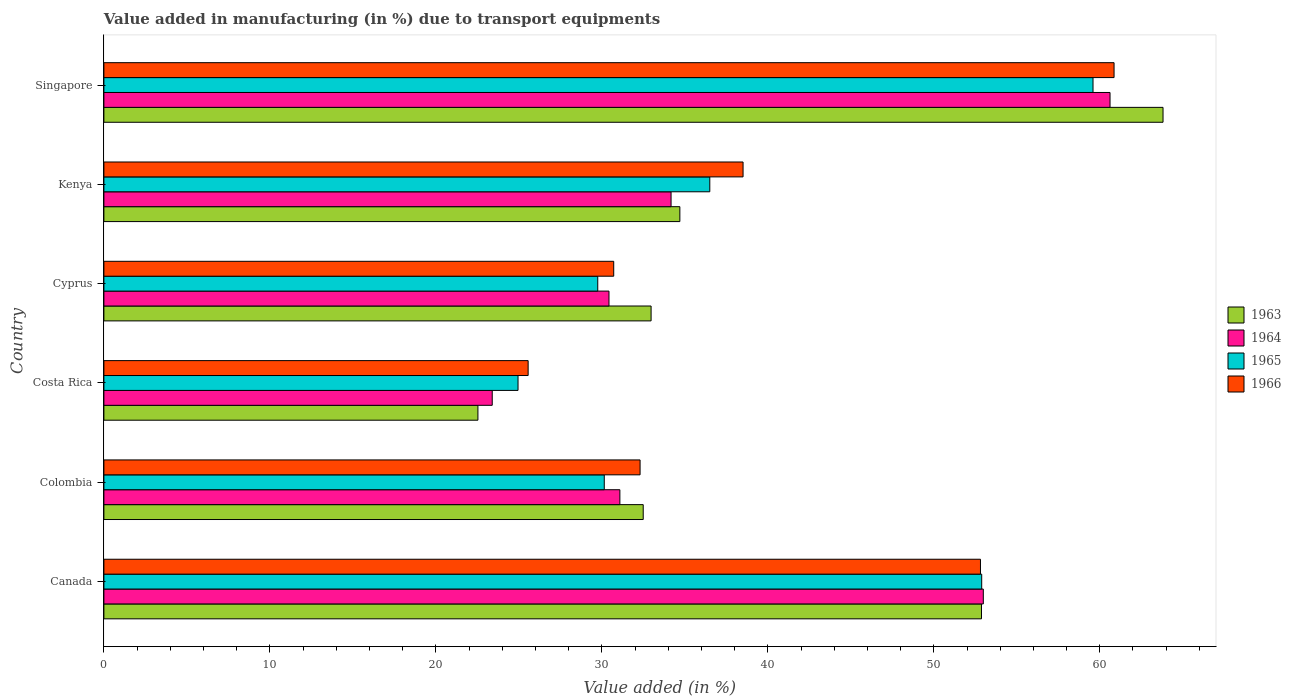How many different coloured bars are there?
Give a very brief answer. 4. How many groups of bars are there?
Give a very brief answer. 6. Are the number of bars per tick equal to the number of legend labels?
Offer a terse response. Yes. Are the number of bars on each tick of the Y-axis equal?
Offer a very short reply. Yes. How many bars are there on the 2nd tick from the top?
Offer a very short reply. 4. How many bars are there on the 5th tick from the bottom?
Offer a terse response. 4. What is the label of the 2nd group of bars from the top?
Your response must be concise. Kenya. What is the percentage of value added in manufacturing due to transport equipments in 1965 in Canada?
Make the answer very short. 52.89. Across all countries, what is the maximum percentage of value added in manufacturing due to transport equipments in 1964?
Ensure brevity in your answer.  60.62. Across all countries, what is the minimum percentage of value added in manufacturing due to transport equipments in 1966?
Give a very brief answer. 25.56. In which country was the percentage of value added in manufacturing due to transport equipments in 1966 maximum?
Your response must be concise. Singapore. What is the total percentage of value added in manufacturing due to transport equipments in 1966 in the graph?
Make the answer very short. 240.76. What is the difference between the percentage of value added in manufacturing due to transport equipments in 1964 in Canada and that in Colombia?
Offer a terse response. 21.9. What is the difference between the percentage of value added in manufacturing due to transport equipments in 1963 in Costa Rica and the percentage of value added in manufacturing due to transport equipments in 1966 in Singapore?
Your answer should be compact. -38.33. What is the average percentage of value added in manufacturing due to transport equipments in 1964 per country?
Offer a very short reply. 38.78. What is the difference between the percentage of value added in manufacturing due to transport equipments in 1965 and percentage of value added in manufacturing due to transport equipments in 1963 in Canada?
Provide a short and direct response. 0.01. What is the ratio of the percentage of value added in manufacturing due to transport equipments in 1963 in Colombia to that in Cyprus?
Your answer should be very brief. 0.99. Is the percentage of value added in manufacturing due to transport equipments in 1964 in Canada less than that in Kenya?
Provide a succinct answer. No. What is the difference between the highest and the second highest percentage of value added in manufacturing due to transport equipments in 1965?
Offer a terse response. 6.71. What is the difference between the highest and the lowest percentage of value added in manufacturing due to transport equipments in 1966?
Your answer should be compact. 35.3. In how many countries, is the percentage of value added in manufacturing due to transport equipments in 1965 greater than the average percentage of value added in manufacturing due to transport equipments in 1965 taken over all countries?
Your answer should be compact. 2. Is it the case that in every country, the sum of the percentage of value added in manufacturing due to transport equipments in 1966 and percentage of value added in manufacturing due to transport equipments in 1963 is greater than the sum of percentage of value added in manufacturing due to transport equipments in 1965 and percentage of value added in manufacturing due to transport equipments in 1964?
Make the answer very short. No. What does the 2nd bar from the top in Cyprus represents?
Your answer should be compact. 1965. What does the 4th bar from the bottom in Singapore represents?
Make the answer very short. 1966. Is it the case that in every country, the sum of the percentage of value added in manufacturing due to transport equipments in 1965 and percentage of value added in manufacturing due to transport equipments in 1966 is greater than the percentage of value added in manufacturing due to transport equipments in 1964?
Keep it short and to the point. Yes. How many bars are there?
Your response must be concise. 24. What is the difference between two consecutive major ticks on the X-axis?
Your answer should be very brief. 10. Are the values on the major ticks of X-axis written in scientific E-notation?
Provide a short and direct response. No. Does the graph contain grids?
Offer a terse response. No. How many legend labels are there?
Give a very brief answer. 4. What is the title of the graph?
Make the answer very short. Value added in manufacturing (in %) due to transport equipments. What is the label or title of the X-axis?
Ensure brevity in your answer.  Value added (in %). What is the label or title of the Y-axis?
Provide a succinct answer. Country. What is the Value added (in %) in 1963 in Canada?
Keep it short and to the point. 52.87. What is the Value added (in %) of 1964 in Canada?
Make the answer very short. 52.98. What is the Value added (in %) in 1965 in Canada?
Ensure brevity in your answer.  52.89. What is the Value added (in %) in 1966 in Canada?
Offer a very short reply. 52.81. What is the Value added (in %) in 1963 in Colombia?
Give a very brief answer. 32.49. What is the Value added (in %) in 1964 in Colombia?
Your answer should be very brief. 31.09. What is the Value added (in %) of 1965 in Colombia?
Ensure brevity in your answer.  30.15. What is the Value added (in %) in 1966 in Colombia?
Ensure brevity in your answer.  32.3. What is the Value added (in %) of 1963 in Costa Rica?
Provide a succinct answer. 22.53. What is the Value added (in %) of 1964 in Costa Rica?
Offer a very short reply. 23.4. What is the Value added (in %) in 1965 in Costa Rica?
Offer a terse response. 24.95. What is the Value added (in %) in 1966 in Costa Rica?
Keep it short and to the point. 25.56. What is the Value added (in %) of 1963 in Cyprus?
Your response must be concise. 32.97. What is the Value added (in %) of 1964 in Cyprus?
Give a very brief answer. 30.43. What is the Value added (in %) of 1965 in Cyprus?
Offer a very short reply. 29.75. What is the Value added (in %) of 1966 in Cyprus?
Make the answer very short. 30.72. What is the Value added (in %) of 1963 in Kenya?
Ensure brevity in your answer.  34.7. What is the Value added (in %) in 1964 in Kenya?
Give a very brief answer. 34.17. What is the Value added (in %) in 1965 in Kenya?
Provide a short and direct response. 36.5. What is the Value added (in %) of 1966 in Kenya?
Make the answer very short. 38.51. What is the Value added (in %) in 1963 in Singapore?
Ensure brevity in your answer.  63.81. What is the Value added (in %) in 1964 in Singapore?
Your answer should be very brief. 60.62. What is the Value added (in %) of 1965 in Singapore?
Your answer should be compact. 59.59. What is the Value added (in %) of 1966 in Singapore?
Give a very brief answer. 60.86. Across all countries, what is the maximum Value added (in %) in 1963?
Offer a terse response. 63.81. Across all countries, what is the maximum Value added (in %) in 1964?
Your response must be concise. 60.62. Across all countries, what is the maximum Value added (in %) of 1965?
Make the answer very short. 59.59. Across all countries, what is the maximum Value added (in %) in 1966?
Offer a terse response. 60.86. Across all countries, what is the minimum Value added (in %) of 1963?
Offer a very short reply. 22.53. Across all countries, what is the minimum Value added (in %) in 1964?
Offer a terse response. 23.4. Across all countries, what is the minimum Value added (in %) of 1965?
Ensure brevity in your answer.  24.95. Across all countries, what is the minimum Value added (in %) in 1966?
Ensure brevity in your answer.  25.56. What is the total Value added (in %) of 1963 in the graph?
Offer a very short reply. 239.38. What is the total Value added (in %) of 1964 in the graph?
Make the answer very short. 232.68. What is the total Value added (in %) of 1965 in the graph?
Offer a very short reply. 233.83. What is the total Value added (in %) of 1966 in the graph?
Offer a terse response. 240.76. What is the difference between the Value added (in %) in 1963 in Canada and that in Colombia?
Your response must be concise. 20.38. What is the difference between the Value added (in %) of 1964 in Canada and that in Colombia?
Your response must be concise. 21.9. What is the difference between the Value added (in %) of 1965 in Canada and that in Colombia?
Give a very brief answer. 22.74. What is the difference between the Value added (in %) of 1966 in Canada and that in Colombia?
Offer a terse response. 20.51. What is the difference between the Value added (in %) of 1963 in Canada and that in Costa Rica?
Offer a very short reply. 30.34. What is the difference between the Value added (in %) in 1964 in Canada and that in Costa Rica?
Give a very brief answer. 29.59. What is the difference between the Value added (in %) of 1965 in Canada and that in Costa Rica?
Ensure brevity in your answer.  27.93. What is the difference between the Value added (in %) in 1966 in Canada and that in Costa Rica?
Ensure brevity in your answer.  27.25. What is the difference between the Value added (in %) of 1963 in Canada and that in Cyprus?
Offer a terse response. 19.91. What is the difference between the Value added (in %) of 1964 in Canada and that in Cyprus?
Provide a short and direct response. 22.55. What is the difference between the Value added (in %) in 1965 in Canada and that in Cyprus?
Give a very brief answer. 23.13. What is the difference between the Value added (in %) in 1966 in Canada and that in Cyprus?
Your response must be concise. 22.1. What is the difference between the Value added (in %) in 1963 in Canada and that in Kenya?
Offer a terse response. 18.17. What is the difference between the Value added (in %) of 1964 in Canada and that in Kenya?
Keep it short and to the point. 18.81. What is the difference between the Value added (in %) in 1965 in Canada and that in Kenya?
Your answer should be very brief. 16.38. What is the difference between the Value added (in %) in 1966 in Canada and that in Kenya?
Provide a short and direct response. 14.3. What is the difference between the Value added (in %) in 1963 in Canada and that in Singapore?
Make the answer very short. -10.94. What is the difference between the Value added (in %) of 1964 in Canada and that in Singapore?
Keep it short and to the point. -7.63. What is the difference between the Value added (in %) in 1965 in Canada and that in Singapore?
Your response must be concise. -6.71. What is the difference between the Value added (in %) of 1966 in Canada and that in Singapore?
Make the answer very short. -8.05. What is the difference between the Value added (in %) in 1963 in Colombia and that in Costa Rica?
Make the answer very short. 9.96. What is the difference between the Value added (in %) of 1964 in Colombia and that in Costa Rica?
Offer a very short reply. 7.69. What is the difference between the Value added (in %) in 1965 in Colombia and that in Costa Rica?
Keep it short and to the point. 5.2. What is the difference between the Value added (in %) of 1966 in Colombia and that in Costa Rica?
Provide a succinct answer. 6.74. What is the difference between the Value added (in %) of 1963 in Colombia and that in Cyprus?
Give a very brief answer. -0.47. What is the difference between the Value added (in %) of 1964 in Colombia and that in Cyprus?
Offer a terse response. 0.66. What is the difference between the Value added (in %) in 1965 in Colombia and that in Cyprus?
Ensure brevity in your answer.  0.39. What is the difference between the Value added (in %) in 1966 in Colombia and that in Cyprus?
Offer a very short reply. 1.59. What is the difference between the Value added (in %) in 1963 in Colombia and that in Kenya?
Your answer should be very brief. -2.21. What is the difference between the Value added (in %) in 1964 in Colombia and that in Kenya?
Give a very brief answer. -3.08. What is the difference between the Value added (in %) of 1965 in Colombia and that in Kenya?
Ensure brevity in your answer.  -6.36. What is the difference between the Value added (in %) of 1966 in Colombia and that in Kenya?
Offer a terse response. -6.2. What is the difference between the Value added (in %) in 1963 in Colombia and that in Singapore?
Make the answer very short. -31.32. What is the difference between the Value added (in %) of 1964 in Colombia and that in Singapore?
Your answer should be compact. -29.53. What is the difference between the Value added (in %) in 1965 in Colombia and that in Singapore?
Offer a terse response. -29.45. What is the difference between the Value added (in %) in 1966 in Colombia and that in Singapore?
Provide a short and direct response. -28.56. What is the difference between the Value added (in %) of 1963 in Costa Rica and that in Cyprus?
Ensure brevity in your answer.  -10.43. What is the difference between the Value added (in %) in 1964 in Costa Rica and that in Cyprus?
Offer a very short reply. -7.03. What is the difference between the Value added (in %) of 1965 in Costa Rica and that in Cyprus?
Make the answer very short. -4.8. What is the difference between the Value added (in %) in 1966 in Costa Rica and that in Cyprus?
Make the answer very short. -5.16. What is the difference between the Value added (in %) in 1963 in Costa Rica and that in Kenya?
Make the answer very short. -12.17. What is the difference between the Value added (in %) of 1964 in Costa Rica and that in Kenya?
Provide a short and direct response. -10.77. What is the difference between the Value added (in %) in 1965 in Costa Rica and that in Kenya?
Ensure brevity in your answer.  -11.55. What is the difference between the Value added (in %) in 1966 in Costa Rica and that in Kenya?
Your answer should be very brief. -12.95. What is the difference between the Value added (in %) of 1963 in Costa Rica and that in Singapore?
Your answer should be compact. -41.28. What is the difference between the Value added (in %) in 1964 in Costa Rica and that in Singapore?
Your answer should be very brief. -37.22. What is the difference between the Value added (in %) in 1965 in Costa Rica and that in Singapore?
Ensure brevity in your answer.  -34.64. What is the difference between the Value added (in %) in 1966 in Costa Rica and that in Singapore?
Keep it short and to the point. -35.3. What is the difference between the Value added (in %) of 1963 in Cyprus and that in Kenya?
Offer a very short reply. -1.73. What is the difference between the Value added (in %) of 1964 in Cyprus and that in Kenya?
Your answer should be compact. -3.74. What is the difference between the Value added (in %) of 1965 in Cyprus and that in Kenya?
Ensure brevity in your answer.  -6.75. What is the difference between the Value added (in %) in 1966 in Cyprus and that in Kenya?
Provide a short and direct response. -7.79. What is the difference between the Value added (in %) of 1963 in Cyprus and that in Singapore?
Your answer should be compact. -30.84. What is the difference between the Value added (in %) of 1964 in Cyprus and that in Singapore?
Your answer should be very brief. -30.19. What is the difference between the Value added (in %) in 1965 in Cyprus and that in Singapore?
Keep it short and to the point. -29.84. What is the difference between the Value added (in %) in 1966 in Cyprus and that in Singapore?
Offer a terse response. -30.14. What is the difference between the Value added (in %) in 1963 in Kenya and that in Singapore?
Your answer should be compact. -29.11. What is the difference between the Value added (in %) in 1964 in Kenya and that in Singapore?
Make the answer very short. -26.45. What is the difference between the Value added (in %) in 1965 in Kenya and that in Singapore?
Your response must be concise. -23.09. What is the difference between the Value added (in %) of 1966 in Kenya and that in Singapore?
Your response must be concise. -22.35. What is the difference between the Value added (in %) in 1963 in Canada and the Value added (in %) in 1964 in Colombia?
Make the answer very short. 21.79. What is the difference between the Value added (in %) in 1963 in Canada and the Value added (in %) in 1965 in Colombia?
Your answer should be compact. 22.73. What is the difference between the Value added (in %) in 1963 in Canada and the Value added (in %) in 1966 in Colombia?
Keep it short and to the point. 20.57. What is the difference between the Value added (in %) in 1964 in Canada and the Value added (in %) in 1965 in Colombia?
Make the answer very short. 22.84. What is the difference between the Value added (in %) in 1964 in Canada and the Value added (in %) in 1966 in Colombia?
Ensure brevity in your answer.  20.68. What is the difference between the Value added (in %) in 1965 in Canada and the Value added (in %) in 1966 in Colombia?
Offer a terse response. 20.58. What is the difference between the Value added (in %) in 1963 in Canada and the Value added (in %) in 1964 in Costa Rica?
Your answer should be very brief. 29.48. What is the difference between the Value added (in %) in 1963 in Canada and the Value added (in %) in 1965 in Costa Rica?
Your answer should be very brief. 27.92. What is the difference between the Value added (in %) in 1963 in Canada and the Value added (in %) in 1966 in Costa Rica?
Give a very brief answer. 27.31. What is the difference between the Value added (in %) in 1964 in Canada and the Value added (in %) in 1965 in Costa Rica?
Your answer should be compact. 28.03. What is the difference between the Value added (in %) in 1964 in Canada and the Value added (in %) in 1966 in Costa Rica?
Provide a short and direct response. 27.42. What is the difference between the Value added (in %) in 1965 in Canada and the Value added (in %) in 1966 in Costa Rica?
Provide a succinct answer. 27.33. What is the difference between the Value added (in %) in 1963 in Canada and the Value added (in %) in 1964 in Cyprus?
Offer a very short reply. 22.44. What is the difference between the Value added (in %) in 1963 in Canada and the Value added (in %) in 1965 in Cyprus?
Keep it short and to the point. 23.12. What is the difference between the Value added (in %) in 1963 in Canada and the Value added (in %) in 1966 in Cyprus?
Your answer should be compact. 22.16. What is the difference between the Value added (in %) of 1964 in Canada and the Value added (in %) of 1965 in Cyprus?
Offer a very short reply. 23.23. What is the difference between the Value added (in %) in 1964 in Canada and the Value added (in %) in 1966 in Cyprus?
Offer a terse response. 22.27. What is the difference between the Value added (in %) of 1965 in Canada and the Value added (in %) of 1966 in Cyprus?
Ensure brevity in your answer.  22.17. What is the difference between the Value added (in %) of 1963 in Canada and the Value added (in %) of 1964 in Kenya?
Your answer should be compact. 18.7. What is the difference between the Value added (in %) in 1963 in Canada and the Value added (in %) in 1965 in Kenya?
Make the answer very short. 16.37. What is the difference between the Value added (in %) of 1963 in Canada and the Value added (in %) of 1966 in Kenya?
Your response must be concise. 14.37. What is the difference between the Value added (in %) of 1964 in Canada and the Value added (in %) of 1965 in Kenya?
Give a very brief answer. 16.48. What is the difference between the Value added (in %) of 1964 in Canada and the Value added (in %) of 1966 in Kenya?
Provide a short and direct response. 14.47. What is the difference between the Value added (in %) in 1965 in Canada and the Value added (in %) in 1966 in Kenya?
Your answer should be very brief. 14.38. What is the difference between the Value added (in %) in 1963 in Canada and the Value added (in %) in 1964 in Singapore?
Your answer should be very brief. -7.74. What is the difference between the Value added (in %) in 1963 in Canada and the Value added (in %) in 1965 in Singapore?
Your answer should be compact. -6.72. What is the difference between the Value added (in %) of 1963 in Canada and the Value added (in %) of 1966 in Singapore?
Ensure brevity in your answer.  -7.99. What is the difference between the Value added (in %) in 1964 in Canada and the Value added (in %) in 1965 in Singapore?
Ensure brevity in your answer.  -6.61. What is the difference between the Value added (in %) of 1964 in Canada and the Value added (in %) of 1966 in Singapore?
Your answer should be very brief. -7.88. What is the difference between the Value added (in %) of 1965 in Canada and the Value added (in %) of 1966 in Singapore?
Your answer should be compact. -7.97. What is the difference between the Value added (in %) of 1963 in Colombia and the Value added (in %) of 1964 in Costa Rica?
Your response must be concise. 9.1. What is the difference between the Value added (in %) of 1963 in Colombia and the Value added (in %) of 1965 in Costa Rica?
Your answer should be very brief. 7.54. What is the difference between the Value added (in %) of 1963 in Colombia and the Value added (in %) of 1966 in Costa Rica?
Ensure brevity in your answer.  6.93. What is the difference between the Value added (in %) in 1964 in Colombia and the Value added (in %) in 1965 in Costa Rica?
Make the answer very short. 6.14. What is the difference between the Value added (in %) of 1964 in Colombia and the Value added (in %) of 1966 in Costa Rica?
Offer a terse response. 5.53. What is the difference between the Value added (in %) in 1965 in Colombia and the Value added (in %) in 1966 in Costa Rica?
Make the answer very short. 4.59. What is the difference between the Value added (in %) in 1963 in Colombia and the Value added (in %) in 1964 in Cyprus?
Your answer should be compact. 2.06. What is the difference between the Value added (in %) of 1963 in Colombia and the Value added (in %) of 1965 in Cyprus?
Give a very brief answer. 2.74. What is the difference between the Value added (in %) in 1963 in Colombia and the Value added (in %) in 1966 in Cyprus?
Offer a terse response. 1.78. What is the difference between the Value added (in %) of 1964 in Colombia and the Value added (in %) of 1965 in Cyprus?
Provide a succinct answer. 1.33. What is the difference between the Value added (in %) of 1964 in Colombia and the Value added (in %) of 1966 in Cyprus?
Make the answer very short. 0.37. What is the difference between the Value added (in %) in 1965 in Colombia and the Value added (in %) in 1966 in Cyprus?
Keep it short and to the point. -0.57. What is the difference between the Value added (in %) of 1963 in Colombia and the Value added (in %) of 1964 in Kenya?
Keep it short and to the point. -1.68. What is the difference between the Value added (in %) of 1963 in Colombia and the Value added (in %) of 1965 in Kenya?
Ensure brevity in your answer.  -4.01. What is the difference between the Value added (in %) in 1963 in Colombia and the Value added (in %) in 1966 in Kenya?
Your response must be concise. -6.01. What is the difference between the Value added (in %) in 1964 in Colombia and the Value added (in %) in 1965 in Kenya?
Ensure brevity in your answer.  -5.42. What is the difference between the Value added (in %) of 1964 in Colombia and the Value added (in %) of 1966 in Kenya?
Offer a very short reply. -7.42. What is the difference between the Value added (in %) in 1965 in Colombia and the Value added (in %) in 1966 in Kenya?
Give a very brief answer. -8.36. What is the difference between the Value added (in %) in 1963 in Colombia and the Value added (in %) in 1964 in Singapore?
Ensure brevity in your answer.  -28.12. What is the difference between the Value added (in %) of 1963 in Colombia and the Value added (in %) of 1965 in Singapore?
Give a very brief answer. -27.1. What is the difference between the Value added (in %) in 1963 in Colombia and the Value added (in %) in 1966 in Singapore?
Offer a terse response. -28.37. What is the difference between the Value added (in %) of 1964 in Colombia and the Value added (in %) of 1965 in Singapore?
Offer a terse response. -28.51. What is the difference between the Value added (in %) in 1964 in Colombia and the Value added (in %) in 1966 in Singapore?
Keep it short and to the point. -29.77. What is the difference between the Value added (in %) of 1965 in Colombia and the Value added (in %) of 1966 in Singapore?
Offer a very short reply. -30.71. What is the difference between the Value added (in %) in 1963 in Costa Rica and the Value added (in %) in 1964 in Cyprus?
Your response must be concise. -7.9. What is the difference between the Value added (in %) in 1963 in Costa Rica and the Value added (in %) in 1965 in Cyprus?
Provide a succinct answer. -7.22. What is the difference between the Value added (in %) in 1963 in Costa Rica and the Value added (in %) in 1966 in Cyprus?
Your answer should be compact. -8.18. What is the difference between the Value added (in %) of 1964 in Costa Rica and the Value added (in %) of 1965 in Cyprus?
Your response must be concise. -6.36. What is the difference between the Value added (in %) of 1964 in Costa Rica and the Value added (in %) of 1966 in Cyprus?
Offer a terse response. -7.32. What is the difference between the Value added (in %) in 1965 in Costa Rica and the Value added (in %) in 1966 in Cyprus?
Give a very brief answer. -5.77. What is the difference between the Value added (in %) in 1963 in Costa Rica and the Value added (in %) in 1964 in Kenya?
Offer a very short reply. -11.64. What is the difference between the Value added (in %) in 1963 in Costa Rica and the Value added (in %) in 1965 in Kenya?
Provide a short and direct response. -13.97. What is the difference between the Value added (in %) of 1963 in Costa Rica and the Value added (in %) of 1966 in Kenya?
Ensure brevity in your answer.  -15.97. What is the difference between the Value added (in %) in 1964 in Costa Rica and the Value added (in %) in 1965 in Kenya?
Your response must be concise. -13.11. What is the difference between the Value added (in %) of 1964 in Costa Rica and the Value added (in %) of 1966 in Kenya?
Give a very brief answer. -15.11. What is the difference between the Value added (in %) of 1965 in Costa Rica and the Value added (in %) of 1966 in Kenya?
Ensure brevity in your answer.  -13.56. What is the difference between the Value added (in %) of 1963 in Costa Rica and the Value added (in %) of 1964 in Singapore?
Your answer should be compact. -38.08. What is the difference between the Value added (in %) in 1963 in Costa Rica and the Value added (in %) in 1965 in Singapore?
Your answer should be compact. -37.06. What is the difference between the Value added (in %) in 1963 in Costa Rica and the Value added (in %) in 1966 in Singapore?
Give a very brief answer. -38.33. What is the difference between the Value added (in %) of 1964 in Costa Rica and the Value added (in %) of 1965 in Singapore?
Ensure brevity in your answer.  -36.19. What is the difference between the Value added (in %) in 1964 in Costa Rica and the Value added (in %) in 1966 in Singapore?
Your response must be concise. -37.46. What is the difference between the Value added (in %) in 1965 in Costa Rica and the Value added (in %) in 1966 in Singapore?
Keep it short and to the point. -35.91. What is the difference between the Value added (in %) of 1963 in Cyprus and the Value added (in %) of 1964 in Kenya?
Keep it short and to the point. -1.2. What is the difference between the Value added (in %) of 1963 in Cyprus and the Value added (in %) of 1965 in Kenya?
Your answer should be compact. -3.54. What is the difference between the Value added (in %) in 1963 in Cyprus and the Value added (in %) in 1966 in Kenya?
Ensure brevity in your answer.  -5.54. What is the difference between the Value added (in %) in 1964 in Cyprus and the Value added (in %) in 1965 in Kenya?
Offer a terse response. -6.07. What is the difference between the Value added (in %) of 1964 in Cyprus and the Value added (in %) of 1966 in Kenya?
Offer a terse response. -8.08. What is the difference between the Value added (in %) in 1965 in Cyprus and the Value added (in %) in 1966 in Kenya?
Offer a very short reply. -8.75. What is the difference between the Value added (in %) of 1963 in Cyprus and the Value added (in %) of 1964 in Singapore?
Offer a terse response. -27.65. What is the difference between the Value added (in %) of 1963 in Cyprus and the Value added (in %) of 1965 in Singapore?
Keep it short and to the point. -26.62. What is the difference between the Value added (in %) in 1963 in Cyprus and the Value added (in %) in 1966 in Singapore?
Make the answer very short. -27.89. What is the difference between the Value added (in %) in 1964 in Cyprus and the Value added (in %) in 1965 in Singapore?
Offer a terse response. -29.16. What is the difference between the Value added (in %) of 1964 in Cyprus and the Value added (in %) of 1966 in Singapore?
Make the answer very short. -30.43. What is the difference between the Value added (in %) of 1965 in Cyprus and the Value added (in %) of 1966 in Singapore?
Your response must be concise. -31.11. What is the difference between the Value added (in %) of 1963 in Kenya and the Value added (in %) of 1964 in Singapore?
Your answer should be very brief. -25.92. What is the difference between the Value added (in %) in 1963 in Kenya and the Value added (in %) in 1965 in Singapore?
Provide a short and direct response. -24.89. What is the difference between the Value added (in %) of 1963 in Kenya and the Value added (in %) of 1966 in Singapore?
Provide a succinct answer. -26.16. What is the difference between the Value added (in %) of 1964 in Kenya and the Value added (in %) of 1965 in Singapore?
Make the answer very short. -25.42. What is the difference between the Value added (in %) in 1964 in Kenya and the Value added (in %) in 1966 in Singapore?
Provide a short and direct response. -26.69. What is the difference between the Value added (in %) of 1965 in Kenya and the Value added (in %) of 1966 in Singapore?
Your response must be concise. -24.36. What is the average Value added (in %) in 1963 per country?
Your response must be concise. 39.9. What is the average Value added (in %) of 1964 per country?
Your response must be concise. 38.78. What is the average Value added (in %) in 1965 per country?
Provide a short and direct response. 38.97. What is the average Value added (in %) of 1966 per country?
Give a very brief answer. 40.13. What is the difference between the Value added (in %) in 1963 and Value added (in %) in 1964 in Canada?
Your answer should be compact. -0.11. What is the difference between the Value added (in %) of 1963 and Value added (in %) of 1965 in Canada?
Your answer should be very brief. -0.01. What is the difference between the Value added (in %) of 1963 and Value added (in %) of 1966 in Canada?
Give a very brief answer. 0.06. What is the difference between the Value added (in %) in 1964 and Value added (in %) in 1965 in Canada?
Provide a succinct answer. 0.1. What is the difference between the Value added (in %) of 1964 and Value added (in %) of 1966 in Canada?
Make the answer very short. 0.17. What is the difference between the Value added (in %) of 1965 and Value added (in %) of 1966 in Canada?
Your answer should be very brief. 0.07. What is the difference between the Value added (in %) of 1963 and Value added (in %) of 1964 in Colombia?
Provide a succinct answer. 1.41. What is the difference between the Value added (in %) in 1963 and Value added (in %) in 1965 in Colombia?
Offer a very short reply. 2.35. What is the difference between the Value added (in %) in 1963 and Value added (in %) in 1966 in Colombia?
Ensure brevity in your answer.  0.19. What is the difference between the Value added (in %) of 1964 and Value added (in %) of 1965 in Colombia?
Keep it short and to the point. 0.94. What is the difference between the Value added (in %) of 1964 and Value added (in %) of 1966 in Colombia?
Provide a succinct answer. -1.22. What is the difference between the Value added (in %) of 1965 and Value added (in %) of 1966 in Colombia?
Your response must be concise. -2.16. What is the difference between the Value added (in %) in 1963 and Value added (in %) in 1964 in Costa Rica?
Your response must be concise. -0.86. What is the difference between the Value added (in %) in 1963 and Value added (in %) in 1965 in Costa Rica?
Give a very brief answer. -2.42. What is the difference between the Value added (in %) of 1963 and Value added (in %) of 1966 in Costa Rica?
Offer a terse response. -3.03. What is the difference between the Value added (in %) of 1964 and Value added (in %) of 1965 in Costa Rica?
Your response must be concise. -1.55. What is the difference between the Value added (in %) of 1964 and Value added (in %) of 1966 in Costa Rica?
Your answer should be compact. -2.16. What is the difference between the Value added (in %) in 1965 and Value added (in %) in 1966 in Costa Rica?
Make the answer very short. -0.61. What is the difference between the Value added (in %) in 1963 and Value added (in %) in 1964 in Cyprus?
Keep it short and to the point. 2.54. What is the difference between the Value added (in %) of 1963 and Value added (in %) of 1965 in Cyprus?
Offer a very short reply. 3.21. What is the difference between the Value added (in %) of 1963 and Value added (in %) of 1966 in Cyprus?
Your answer should be very brief. 2.25. What is the difference between the Value added (in %) of 1964 and Value added (in %) of 1965 in Cyprus?
Make the answer very short. 0.68. What is the difference between the Value added (in %) of 1964 and Value added (in %) of 1966 in Cyprus?
Offer a terse response. -0.29. What is the difference between the Value added (in %) in 1965 and Value added (in %) in 1966 in Cyprus?
Offer a very short reply. -0.96. What is the difference between the Value added (in %) in 1963 and Value added (in %) in 1964 in Kenya?
Keep it short and to the point. 0.53. What is the difference between the Value added (in %) of 1963 and Value added (in %) of 1965 in Kenya?
Your answer should be very brief. -1.8. What is the difference between the Value added (in %) in 1963 and Value added (in %) in 1966 in Kenya?
Your answer should be very brief. -3.81. What is the difference between the Value added (in %) of 1964 and Value added (in %) of 1965 in Kenya?
Ensure brevity in your answer.  -2.33. What is the difference between the Value added (in %) of 1964 and Value added (in %) of 1966 in Kenya?
Give a very brief answer. -4.34. What is the difference between the Value added (in %) of 1965 and Value added (in %) of 1966 in Kenya?
Keep it short and to the point. -2. What is the difference between the Value added (in %) of 1963 and Value added (in %) of 1964 in Singapore?
Ensure brevity in your answer.  3.19. What is the difference between the Value added (in %) of 1963 and Value added (in %) of 1965 in Singapore?
Your answer should be compact. 4.22. What is the difference between the Value added (in %) in 1963 and Value added (in %) in 1966 in Singapore?
Offer a terse response. 2.95. What is the difference between the Value added (in %) of 1964 and Value added (in %) of 1965 in Singapore?
Ensure brevity in your answer.  1.03. What is the difference between the Value added (in %) of 1964 and Value added (in %) of 1966 in Singapore?
Provide a short and direct response. -0.24. What is the difference between the Value added (in %) in 1965 and Value added (in %) in 1966 in Singapore?
Keep it short and to the point. -1.27. What is the ratio of the Value added (in %) of 1963 in Canada to that in Colombia?
Keep it short and to the point. 1.63. What is the ratio of the Value added (in %) of 1964 in Canada to that in Colombia?
Offer a terse response. 1.7. What is the ratio of the Value added (in %) of 1965 in Canada to that in Colombia?
Give a very brief answer. 1.75. What is the ratio of the Value added (in %) in 1966 in Canada to that in Colombia?
Make the answer very short. 1.63. What is the ratio of the Value added (in %) in 1963 in Canada to that in Costa Rica?
Make the answer very short. 2.35. What is the ratio of the Value added (in %) of 1964 in Canada to that in Costa Rica?
Give a very brief answer. 2.26. What is the ratio of the Value added (in %) in 1965 in Canada to that in Costa Rica?
Make the answer very short. 2.12. What is the ratio of the Value added (in %) in 1966 in Canada to that in Costa Rica?
Give a very brief answer. 2.07. What is the ratio of the Value added (in %) of 1963 in Canada to that in Cyprus?
Offer a terse response. 1.6. What is the ratio of the Value added (in %) in 1964 in Canada to that in Cyprus?
Give a very brief answer. 1.74. What is the ratio of the Value added (in %) of 1965 in Canada to that in Cyprus?
Your answer should be compact. 1.78. What is the ratio of the Value added (in %) in 1966 in Canada to that in Cyprus?
Provide a short and direct response. 1.72. What is the ratio of the Value added (in %) in 1963 in Canada to that in Kenya?
Provide a short and direct response. 1.52. What is the ratio of the Value added (in %) in 1964 in Canada to that in Kenya?
Make the answer very short. 1.55. What is the ratio of the Value added (in %) in 1965 in Canada to that in Kenya?
Provide a succinct answer. 1.45. What is the ratio of the Value added (in %) in 1966 in Canada to that in Kenya?
Provide a succinct answer. 1.37. What is the ratio of the Value added (in %) of 1963 in Canada to that in Singapore?
Offer a very short reply. 0.83. What is the ratio of the Value added (in %) of 1964 in Canada to that in Singapore?
Offer a very short reply. 0.87. What is the ratio of the Value added (in %) in 1965 in Canada to that in Singapore?
Offer a terse response. 0.89. What is the ratio of the Value added (in %) in 1966 in Canada to that in Singapore?
Provide a succinct answer. 0.87. What is the ratio of the Value added (in %) of 1963 in Colombia to that in Costa Rica?
Your response must be concise. 1.44. What is the ratio of the Value added (in %) of 1964 in Colombia to that in Costa Rica?
Offer a terse response. 1.33. What is the ratio of the Value added (in %) in 1965 in Colombia to that in Costa Rica?
Keep it short and to the point. 1.21. What is the ratio of the Value added (in %) in 1966 in Colombia to that in Costa Rica?
Make the answer very short. 1.26. What is the ratio of the Value added (in %) of 1963 in Colombia to that in Cyprus?
Offer a very short reply. 0.99. What is the ratio of the Value added (in %) of 1964 in Colombia to that in Cyprus?
Ensure brevity in your answer.  1.02. What is the ratio of the Value added (in %) in 1965 in Colombia to that in Cyprus?
Make the answer very short. 1.01. What is the ratio of the Value added (in %) of 1966 in Colombia to that in Cyprus?
Provide a short and direct response. 1.05. What is the ratio of the Value added (in %) in 1963 in Colombia to that in Kenya?
Provide a short and direct response. 0.94. What is the ratio of the Value added (in %) in 1964 in Colombia to that in Kenya?
Ensure brevity in your answer.  0.91. What is the ratio of the Value added (in %) in 1965 in Colombia to that in Kenya?
Your answer should be very brief. 0.83. What is the ratio of the Value added (in %) in 1966 in Colombia to that in Kenya?
Offer a very short reply. 0.84. What is the ratio of the Value added (in %) of 1963 in Colombia to that in Singapore?
Ensure brevity in your answer.  0.51. What is the ratio of the Value added (in %) of 1964 in Colombia to that in Singapore?
Make the answer very short. 0.51. What is the ratio of the Value added (in %) in 1965 in Colombia to that in Singapore?
Your answer should be compact. 0.51. What is the ratio of the Value added (in %) of 1966 in Colombia to that in Singapore?
Give a very brief answer. 0.53. What is the ratio of the Value added (in %) in 1963 in Costa Rica to that in Cyprus?
Make the answer very short. 0.68. What is the ratio of the Value added (in %) of 1964 in Costa Rica to that in Cyprus?
Your answer should be very brief. 0.77. What is the ratio of the Value added (in %) in 1965 in Costa Rica to that in Cyprus?
Keep it short and to the point. 0.84. What is the ratio of the Value added (in %) in 1966 in Costa Rica to that in Cyprus?
Keep it short and to the point. 0.83. What is the ratio of the Value added (in %) of 1963 in Costa Rica to that in Kenya?
Offer a very short reply. 0.65. What is the ratio of the Value added (in %) of 1964 in Costa Rica to that in Kenya?
Keep it short and to the point. 0.68. What is the ratio of the Value added (in %) in 1965 in Costa Rica to that in Kenya?
Give a very brief answer. 0.68. What is the ratio of the Value added (in %) in 1966 in Costa Rica to that in Kenya?
Your answer should be compact. 0.66. What is the ratio of the Value added (in %) in 1963 in Costa Rica to that in Singapore?
Ensure brevity in your answer.  0.35. What is the ratio of the Value added (in %) in 1964 in Costa Rica to that in Singapore?
Provide a short and direct response. 0.39. What is the ratio of the Value added (in %) in 1965 in Costa Rica to that in Singapore?
Your answer should be compact. 0.42. What is the ratio of the Value added (in %) in 1966 in Costa Rica to that in Singapore?
Your response must be concise. 0.42. What is the ratio of the Value added (in %) of 1963 in Cyprus to that in Kenya?
Your response must be concise. 0.95. What is the ratio of the Value added (in %) in 1964 in Cyprus to that in Kenya?
Your response must be concise. 0.89. What is the ratio of the Value added (in %) of 1965 in Cyprus to that in Kenya?
Your answer should be very brief. 0.82. What is the ratio of the Value added (in %) of 1966 in Cyprus to that in Kenya?
Keep it short and to the point. 0.8. What is the ratio of the Value added (in %) of 1963 in Cyprus to that in Singapore?
Your answer should be compact. 0.52. What is the ratio of the Value added (in %) of 1964 in Cyprus to that in Singapore?
Your response must be concise. 0.5. What is the ratio of the Value added (in %) of 1965 in Cyprus to that in Singapore?
Keep it short and to the point. 0.5. What is the ratio of the Value added (in %) in 1966 in Cyprus to that in Singapore?
Keep it short and to the point. 0.5. What is the ratio of the Value added (in %) in 1963 in Kenya to that in Singapore?
Your answer should be compact. 0.54. What is the ratio of the Value added (in %) of 1964 in Kenya to that in Singapore?
Ensure brevity in your answer.  0.56. What is the ratio of the Value added (in %) in 1965 in Kenya to that in Singapore?
Your answer should be very brief. 0.61. What is the ratio of the Value added (in %) in 1966 in Kenya to that in Singapore?
Your answer should be compact. 0.63. What is the difference between the highest and the second highest Value added (in %) in 1963?
Provide a succinct answer. 10.94. What is the difference between the highest and the second highest Value added (in %) in 1964?
Your answer should be very brief. 7.63. What is the difference between the highest and the second highest Value added (in %) in 1965?
Ensure brevity in your answer.  6.71. What is the difference between the highest and the second highest Value added (in %) in 1966?
Keep it short and to the point. 8.05. What is the difference between the highest and the lowest Value added (in %) in 1963?
Offer a terse response. 41.28. What is the difference between the highest and the lowest Value added (in %) in 1964?
Keep it short and to the point. 37.22. What is the difference between the highest and the lowest Value added (in %) in 1965?
Offer a terse response. 34.64. What is the difference between the highest and the lowest Value added (in %) of 1966?
Make the answer very short. 35.3. 